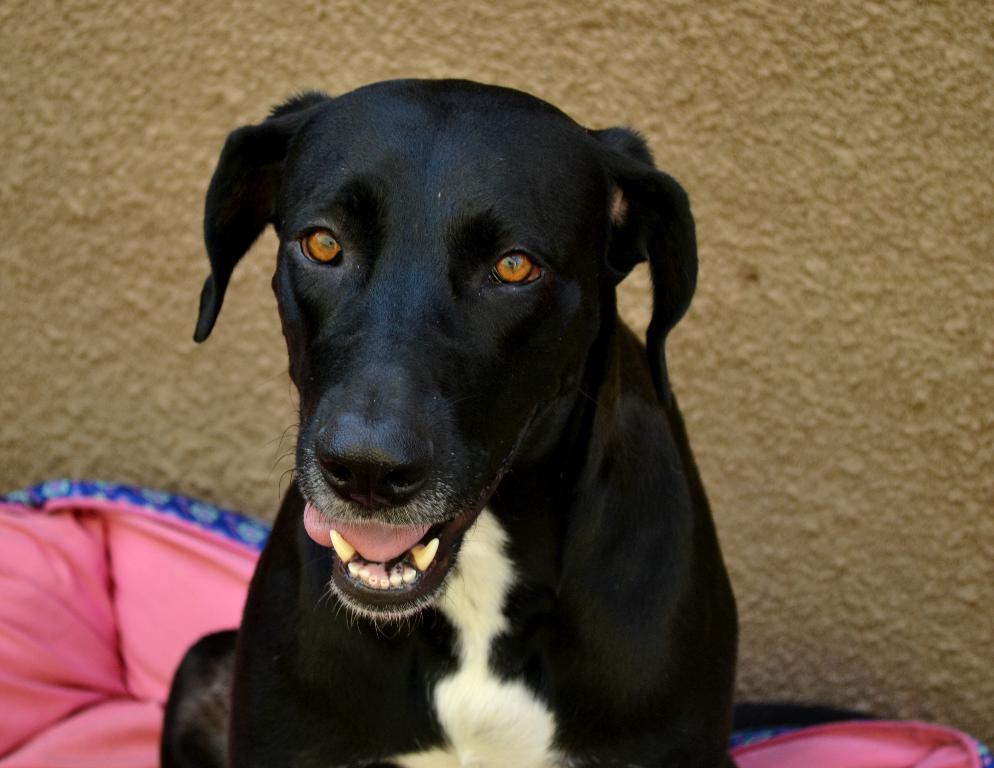In one or two sentences, can you explain what this image depicts? In this image we can see a dog and pink color object, in the background there is a wall. 